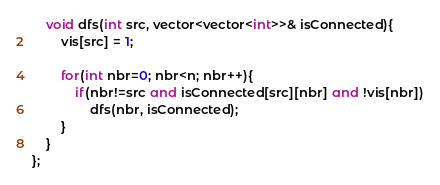<code> <loc_0><loc_0><loc_500><loc_500><_C++_>    void dfs(int src, vector<vector<int>>& isConnected){
        vis[src] = 1;
        
        for(int nbr=0; nbr<n; nbr++){
            if(nbr!=src and isConnected[src][nbr] and !vis[nbr])
                dfs(nbr, isConnected);
        }
    }
};
</code> 